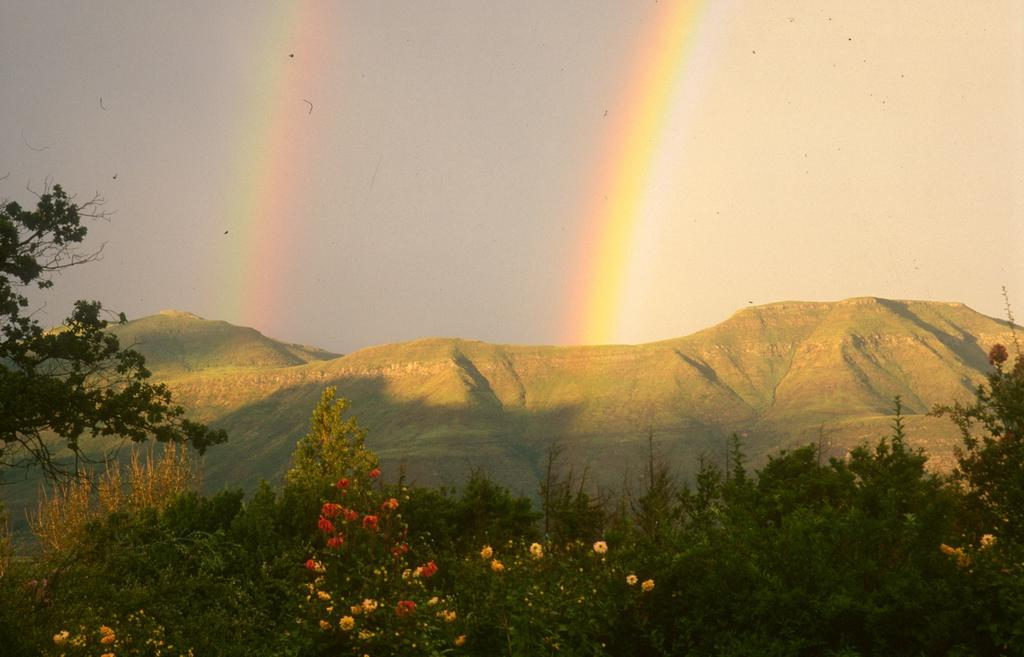What type of vegetation can be seen in the image? There are trees and plants with flowers in the image. What can be seen in the background of the image? There are mountains in the background of the image. What is visible in the sky in the image? There is a double rainbow in the sky. How many rainbows can be seen in the sky? There is a double rainbow in the sky, which means two rainbows can be seen. What type of tin can be seen in the stomach of the person in the image? There is no person present in the image, and therefore no stomach or tin can be seen. 